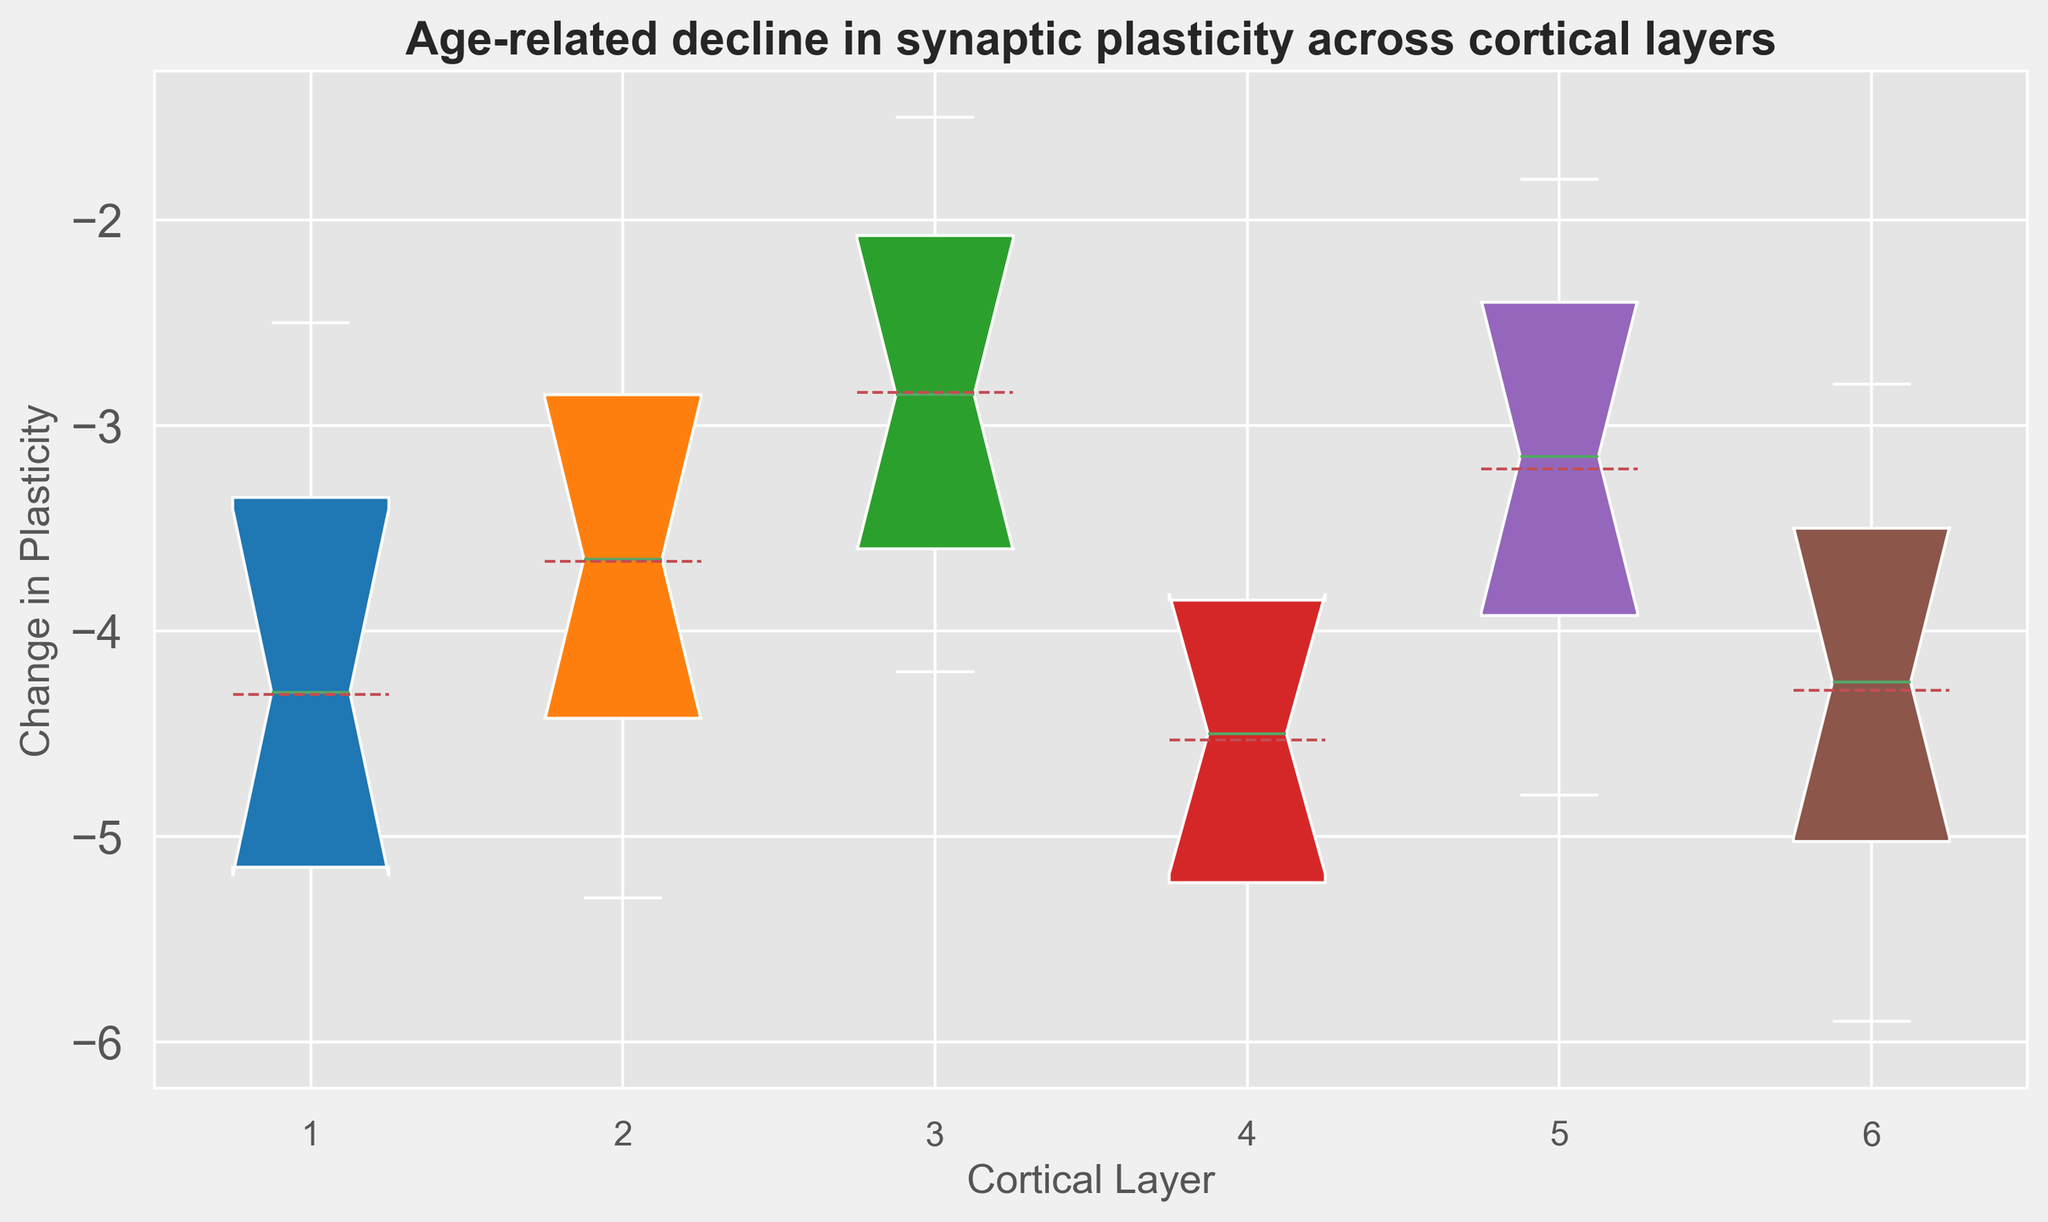How does the median change in synaptic plasticity compare across different layers? The plot shows the medians as the center line within the box. By comparing these lines across different layers, we can see the general trend. The medians decline from layer 1 to layer 4, then there is a less steep decline from layer 4 to layer 6.
Answer: Layer 1 has the least median decline, and layer 6 has the most Which cortical layer exhibits the greatest variability in synaptic plasticity change? Variability is indicated by the length of the interquartile range (IQR), represented by the height of the boxes. The wider the box, the greater the variability. By comparing the height of the boxes, layer 1 has the tallest box, indicating the greatest variability.
Answer: Layer 1 What is the relationship between cortical layers and the mean change in synaptic plasticity? The mean is shown as a line within the notch of the box plot. By visually inspecting these lines, we can infer how the mean value of synaptic plasticity changes across the layers. The means decrease progressively from layer 1 to layer 6.
Answer: Mean decline increases from layer 1 to layer 6 Which cortical layer has the smallest decline in synaptic plasticity at age 75? The endpoints of the whiskers represent the data range. By focusing on the points at age 75 across different layers, the decline values appear to be closest to zero in layer 3.
Answer: Layer 3 What does the mean line within the box plot indicate about synaptic plasticity across different layers? The mean line in each box provides an average decline in synaptic plasticity for each layer. By observing these lines, one can determine that the decline increases as we move from layer 1 to layer 6.
Answer: Indicates increasing decline from layer 1 to layer 6 Is there an age cohort where the change in synaptic plasticity is approximately the same across all layers? By examining the boxes and whiskers for each cohort along the age axis, between ages 40 and 50 there is a convergence of plasticity changes across all layers.
Answer: Ages 40 to 50 Which cortical layer shows the most significant decline in synaptic plasticity by age 70 as compared to age 30? To determine this, compare the change in plasticity at age 70 against the changes at age 30 across layers. The difference is most pronounced for layer 1, where the change goes from -2.5 to -5.8.
Answer: Layer 1 